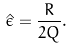<formula> <loc_0><loc_0><loc_500><loc_500>\hat { \epsilon } = \frac { R } { 2 Q } .</formula> 